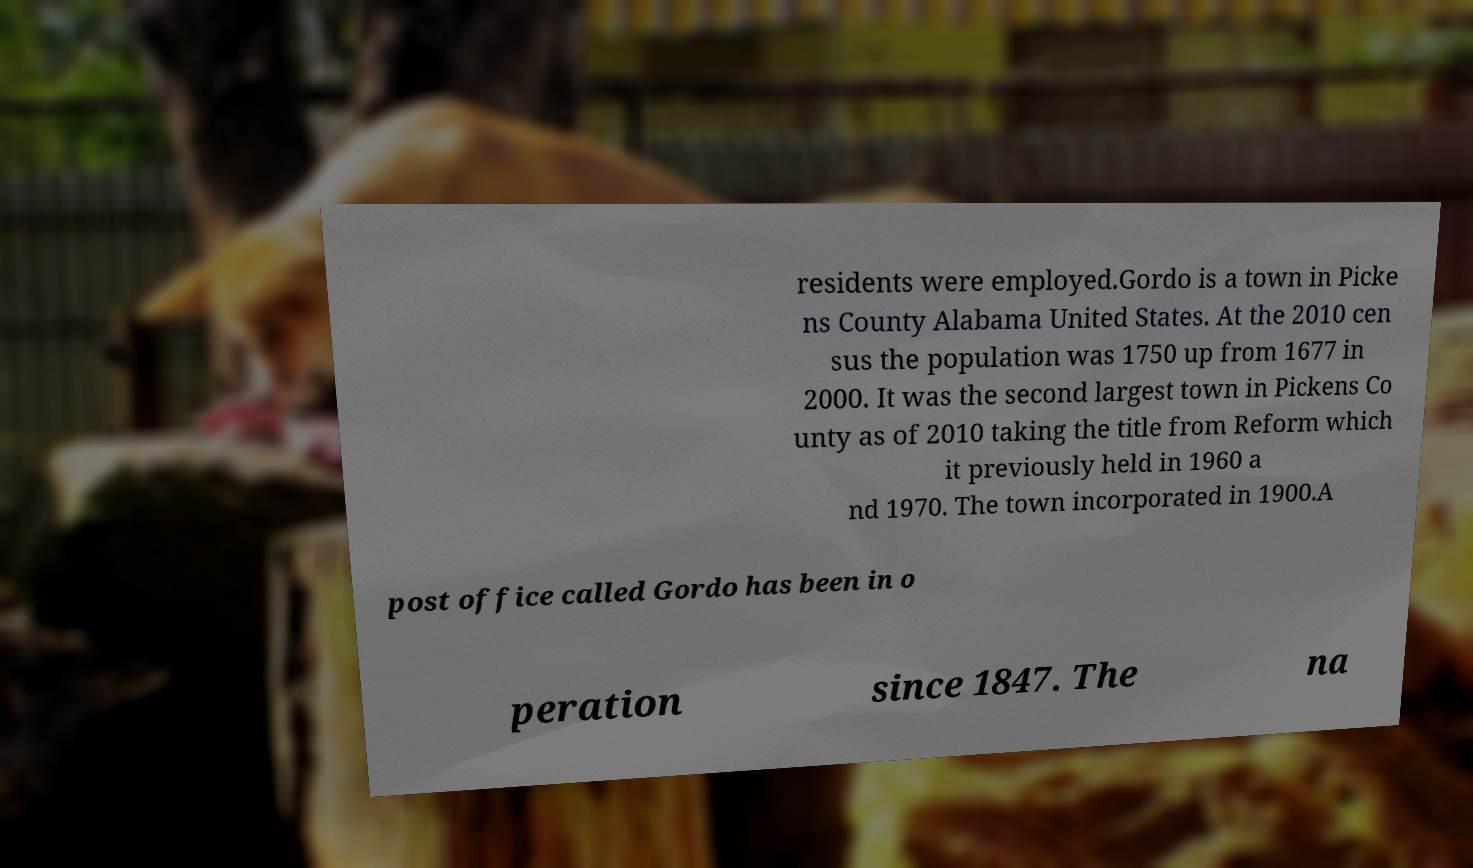For documentation purposes, I need the text within this image transcribed. Could you provide that? residents were employed.Gordo is a town in Picke ns County Alabama United States. At the 2010 cen sus the population was 1750 up from 1677 in 2000. It was the second largest town in Pickens Co unty as of 2010 taking the title from Reform which it previously held in 1960 a nd 1970. The town incorporated in 1900.A post office called Gordo has been in o peration since 1847. The na 